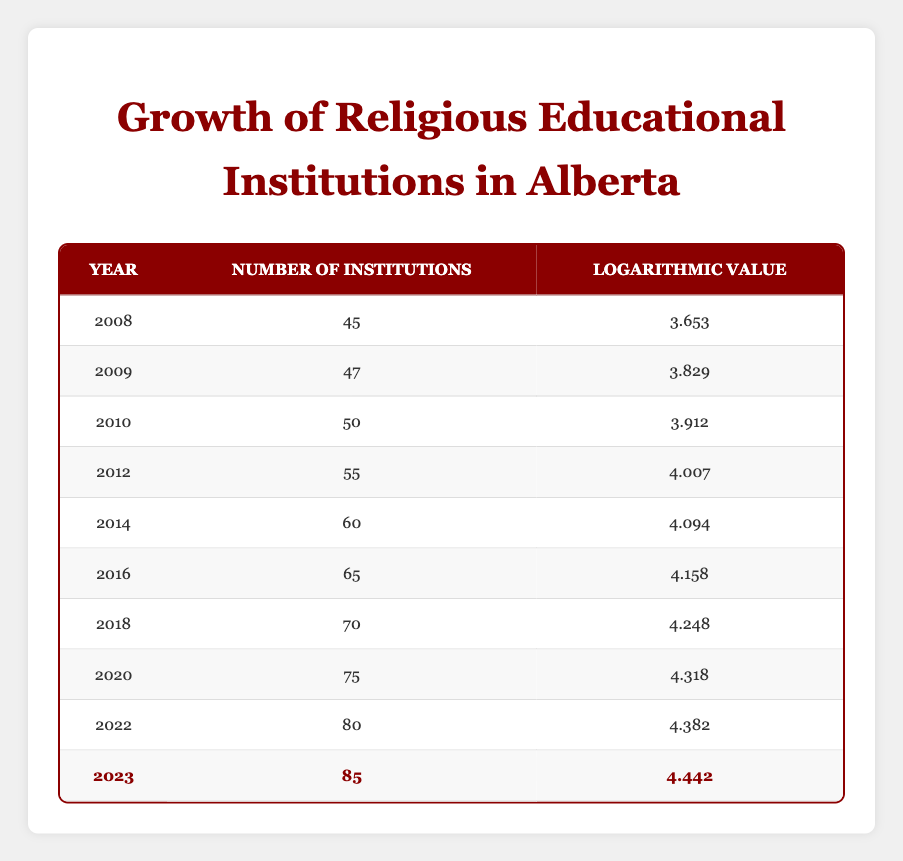What was the number of religious educational institutions in Alberta in 2010? From the table, the row for the year 2010 shows that there were 50 institutions.
Answer: 50 How many religious educational institutions were there in 2023 compared to 2008? In 2023, there were 85 institutions, and in 2008, there were 45 institutions. The difference is 85 - 45 = 40.
Answer: 40 Did the number of institutions increase every year from 2008 to 2023? Referring to the table, the number of institutions increases for each year listed from 2008 to 2023, indicating a consistent upward trend.
Answer: Yes What is the average number of religious educational institutions from 2008 to 2023? The total number of institutions from each year is (45 + 47 + 50 + 55 + 60 + 65 + 70 + 75 + 80 + 85) =  735. Since there are 10 years, the average is 735 / 10 = 73.5.
Answer: 73.5 What was the logarithmic value of the number of institutions in the year with the highest number? By examining the years, 2023 has the highest number of institutions at 85, which corresponds to a logarithmic value of 4.442.
Answer: 4.442 What is the difference in logarithmic values between 2020 and 2022? The logarithmic value for 2020 is 4.318, and for 2022 it is 4.382. The difference is 4.382 - 4.318 = 0.064.
Answer: 0.064 How many years had more than 60 religious educational institutions? Observing the table, the years 2014 (60), 2016 (65), 2018 (70), 2020 (75), 2022 (80), and 2023 (85) all had more than 60 institutions, which totals to 6 years.
Answer: 6 What was the overall increase in the number of institutions from 2008 to 2022? In 2008, there were 45 institutions, and by 2022, the count had reached 80. The overall increase is 80 - 45 = 35.
Answer: 35 Did the number of religious educational institutions double from 2008 to 2023? In 2008, the number of institutions was 45, and in 2023 it was 85. Since double of 45 is 90, which is greater than 85, the number did not double during that period.
Answer: No 